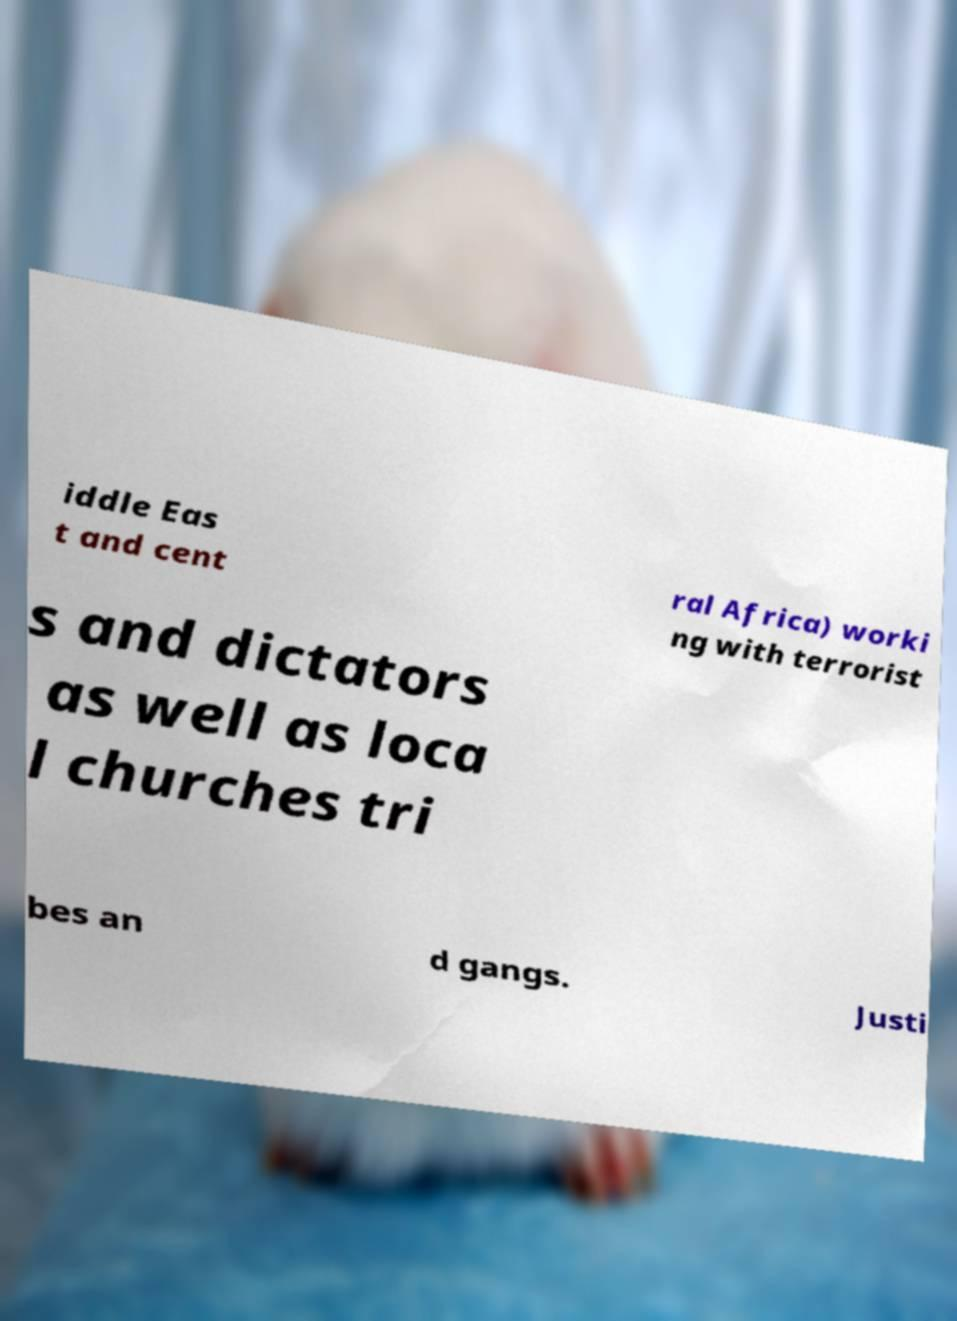Please identify and transcribe the text found in this image. iddle Eas t and cent ral Africa) worki ng with terrorist s and dictators as well as loca l churches tri bes an d gangs. Justi 